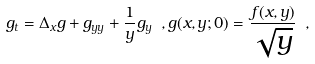Convert formula to latex. <formula><loc_0><loc_0><loc_500><loc_500>g _ { t } = \Delta _ { x } g + g _ { y y } + \frac { 1 } { y } g _ { y } \ , g ( x , y ; 0 ) = \frac { f ( x , y ) } { \sqrt { y } } \ ,</formula> 